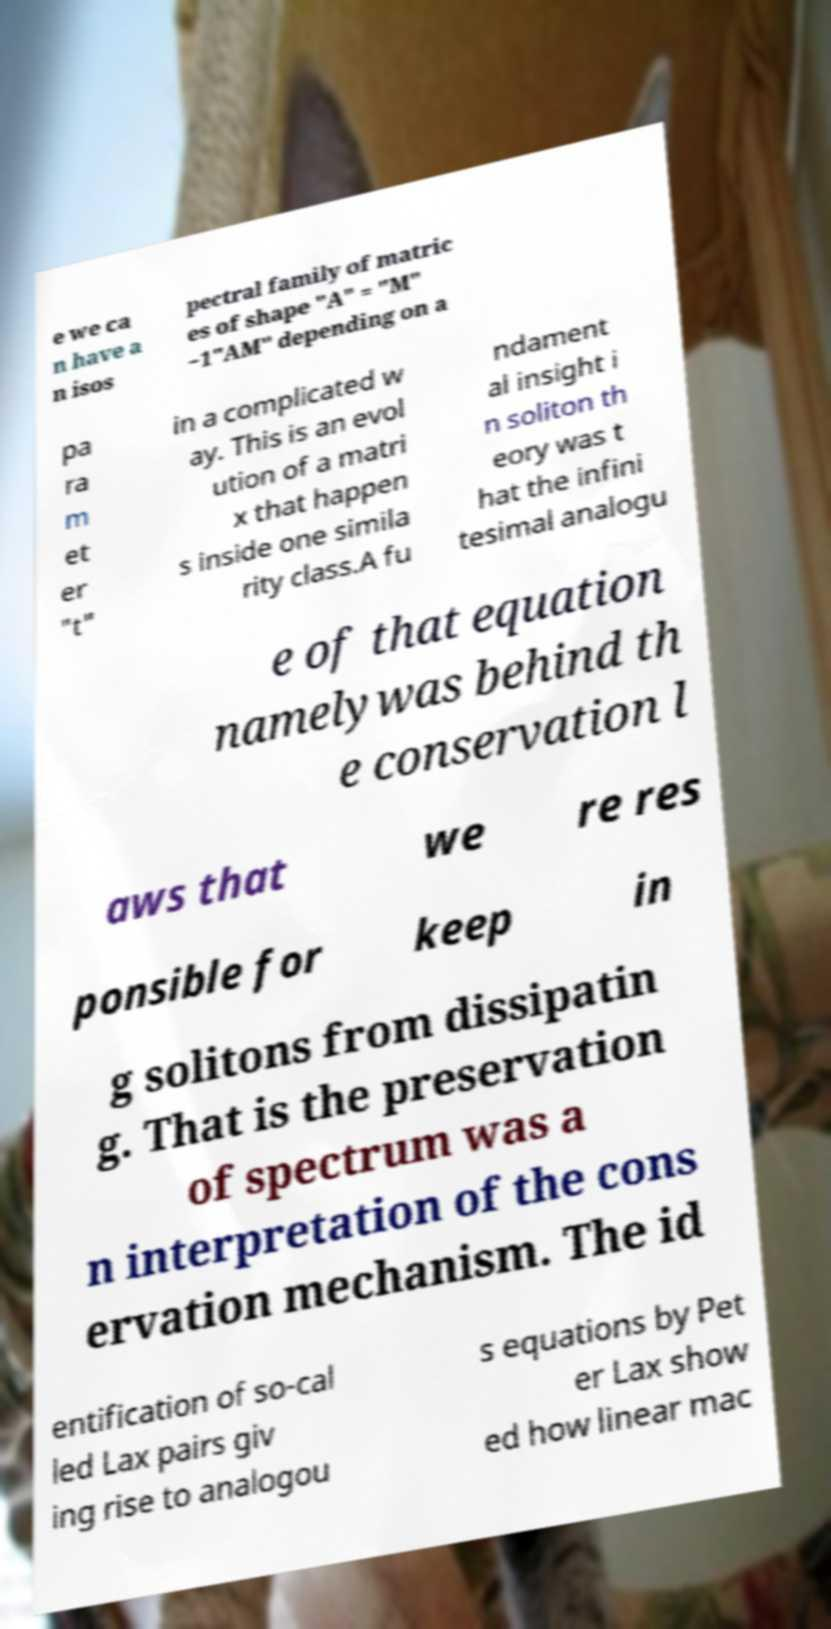I need the written content from this picture converted into text. Can you do that? e we ca n have a n isos pectral family of matric es of shape "A" = "M" −1"AM" depending on a pa ra m et er "t" in a complicated w ay. This is an evol ution of a matri x that happen s inside one simila rity class.A fu ndament al insight i n soliton th eory was t hat the infini tesimal analogu e of that equation namelywas behind th e conservation l aws that we re res ponsible for keep in g solitons from dissipatin g. That is the preservation of spectrum was a n interpretation of the cons ervation mechanism. The id entification of so-cal led Lax pairs giv ing rise to analogou s equations by Pet er Lax show ed how linear mac 